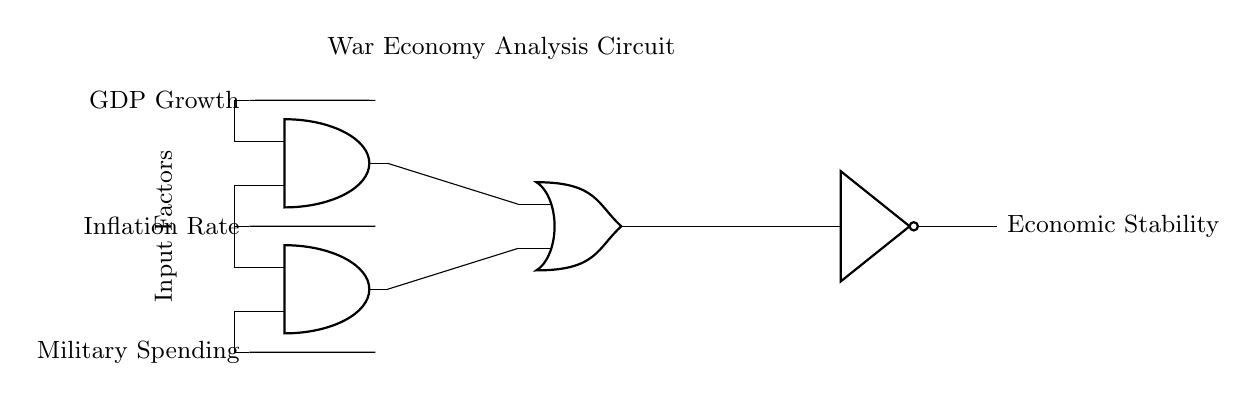What are the input factors in this circuit? The circuit has three input factors: GDP Growth, Inflation Rate, and Military Spending, as labeled on the left side.
Answer: GDP Growth, Inflation Rate, Military Spending How many AND gates are used in this circuit? The circuit diagram shows two AND gates connected to the inputs, which are indicated by the symbols for AND ports.
Answer: 2 What is the output of this logic gate circuit? The output of the logic gate circuit is labeled as "Economic Stability," which is derived from the logical operations performed by the gates.
Answer: Economic Stability Which components are used to determine Economic Stability? Economic Stability is determined by the outputs of two AND gates fed into an OR gate, followed by a NOT gate, indicating a combination of logic operations.
Answer: AND gates, OR gate, NOT gate What logical operations are used to analyze the financial data trends? The circuit uses AND operations between GDP Growth, Inflation Rate, and Military Spending, and then they are combined through an OR operation followed by negation using a NOT operation.
Answer: AND, OR, NOT What does the NOT gate represent in this analysis? The NOT gate represents negation, indicating that the output of the preceding logic must be inverted to analyze Economic Stability in the context of wartime economic conditions.
Answer: Negation 